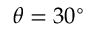Convert formula to latex. <formula><loc_0><loc_0><loc_500><loc_500>\theta = 3 0 ^ { \circ }</formula> 